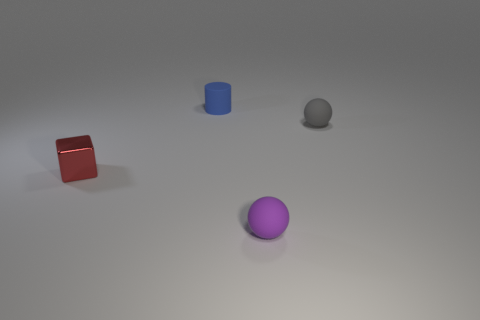Are there any other things that have the same size as the purple rubber ball?
Give a very brief answer. Yes. The cylinder that is the same material as the gray ball is what color?
Give a very brief answer. Blue. Does the purple rubber object have the same shape as the blue matte thing?
Your answer should be compact. No. How many tiny objects are on the left side of the tiny purple sphere and behind the small red metal cube?
Keep it short and to the point. 1. How many matte objects are gray balls or tiny red objects?
Your answer should be very brief. 1. What is the size of the rubber thing that is behind the small ball behind the metallic cube?
Offer a very short reply. Small. Are there any purple spheres that are in front of the small rubber object that is on the right side of the small sphere in front of the small red cube?
Give a very brief answer. Yes. Do the small sphere in front of the small red thing and the tiny object that is behind the tiny gray ball have the same material?
Make the answer very short. Yes. How many things are either yellow rubber blocks or small matte things that are behind the small metallic cube?
Make the answer very short. 2. How many small purple matte things are the same shape as the tiny blue object?
Your response must be concise. 0. 